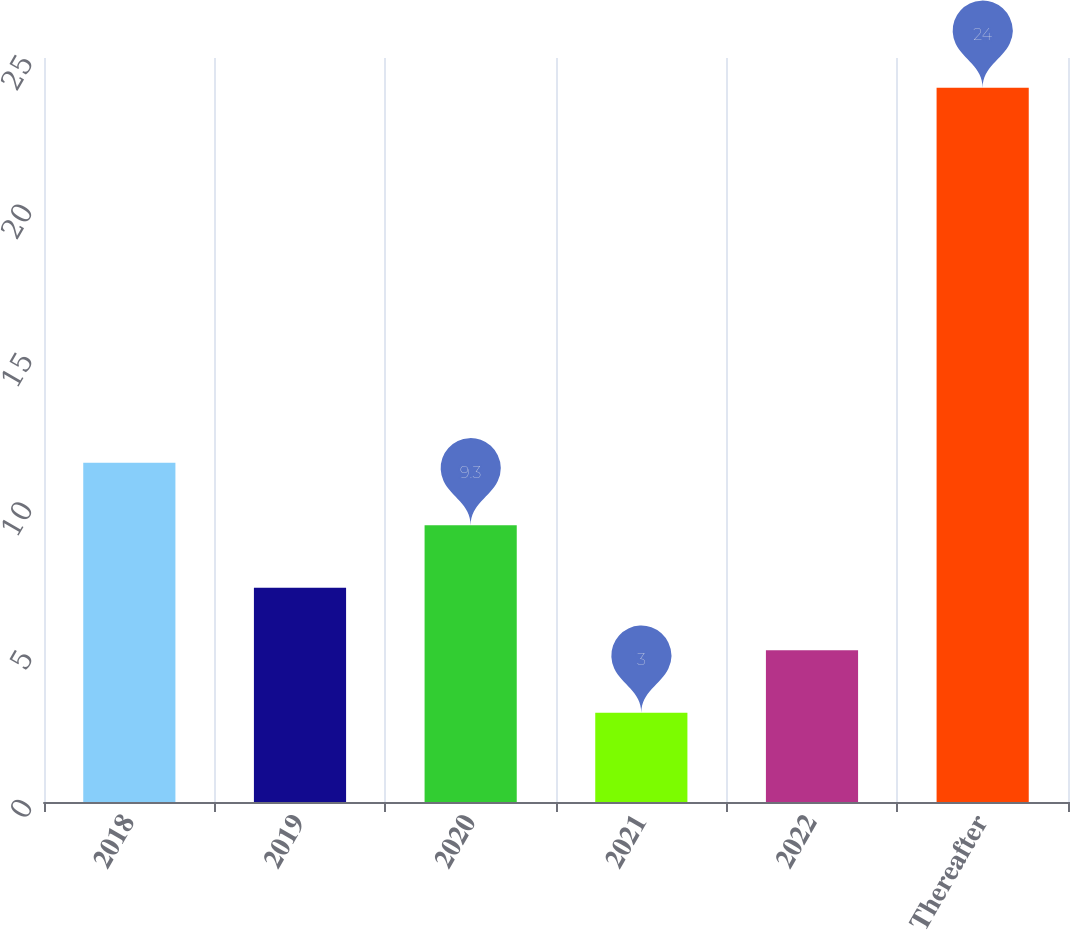Convert chart. <chart><loc_0><loc_0><loc_500><loc_500><bar_chart><fcel>2018<fcel>2019<fcel>2020<fcel>2021<fcel>2022<fcel>Thereafter<nl><fcel>11.4<fcel>7.2<fcel>9.3<fcel>3<fcel>5.1<fcel>24<nl></chart> 